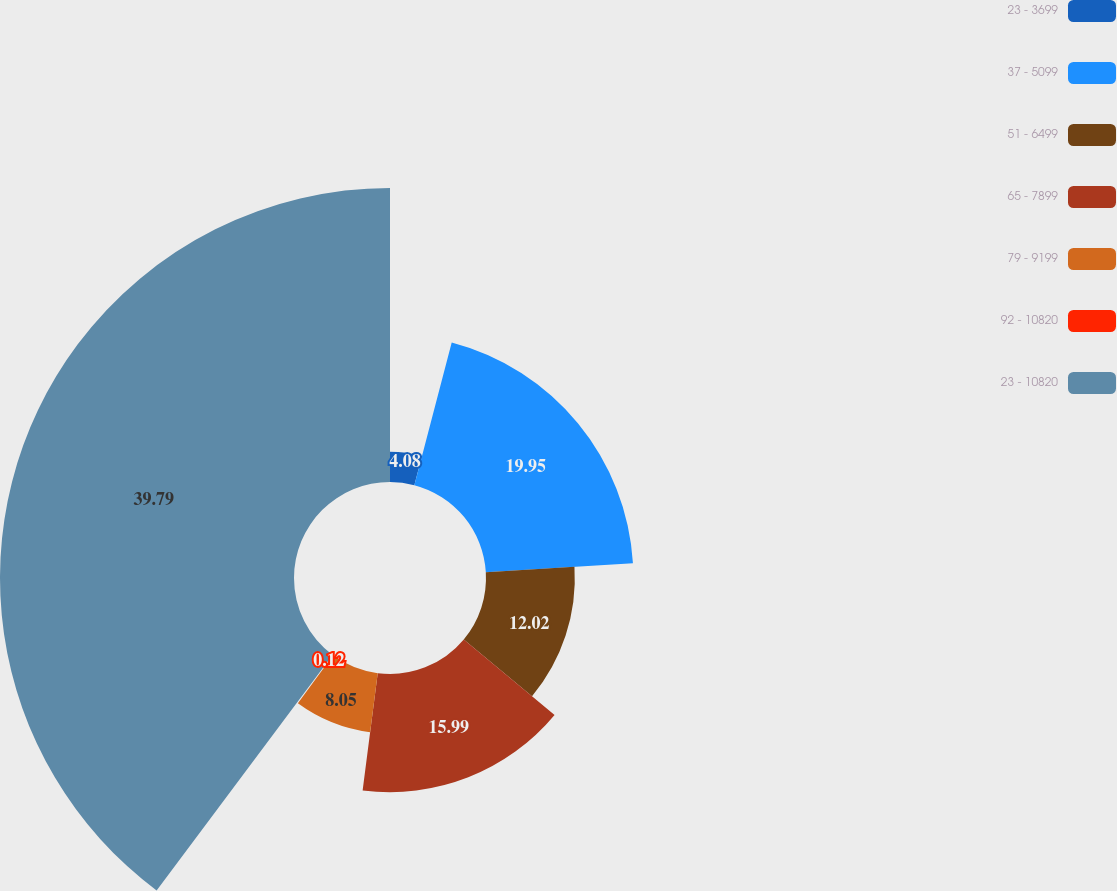<chart> <loc_0><loc_0><loc_500><loc_500><pie_chart><fcel>23 - 3699<fcel>37 - 5099<fcel>51 - 6499<fcel>65 - 7899<fcel>79 - 9199<fcel>92 - 10820<fcel>23 - 10820<nl><fcel>4.08%<fcel>19.95%<fcel>12.02%<fcel>15.99%<fcel>8.05%<fcel>0.12%<fcel>39.79%<nl></chart> 